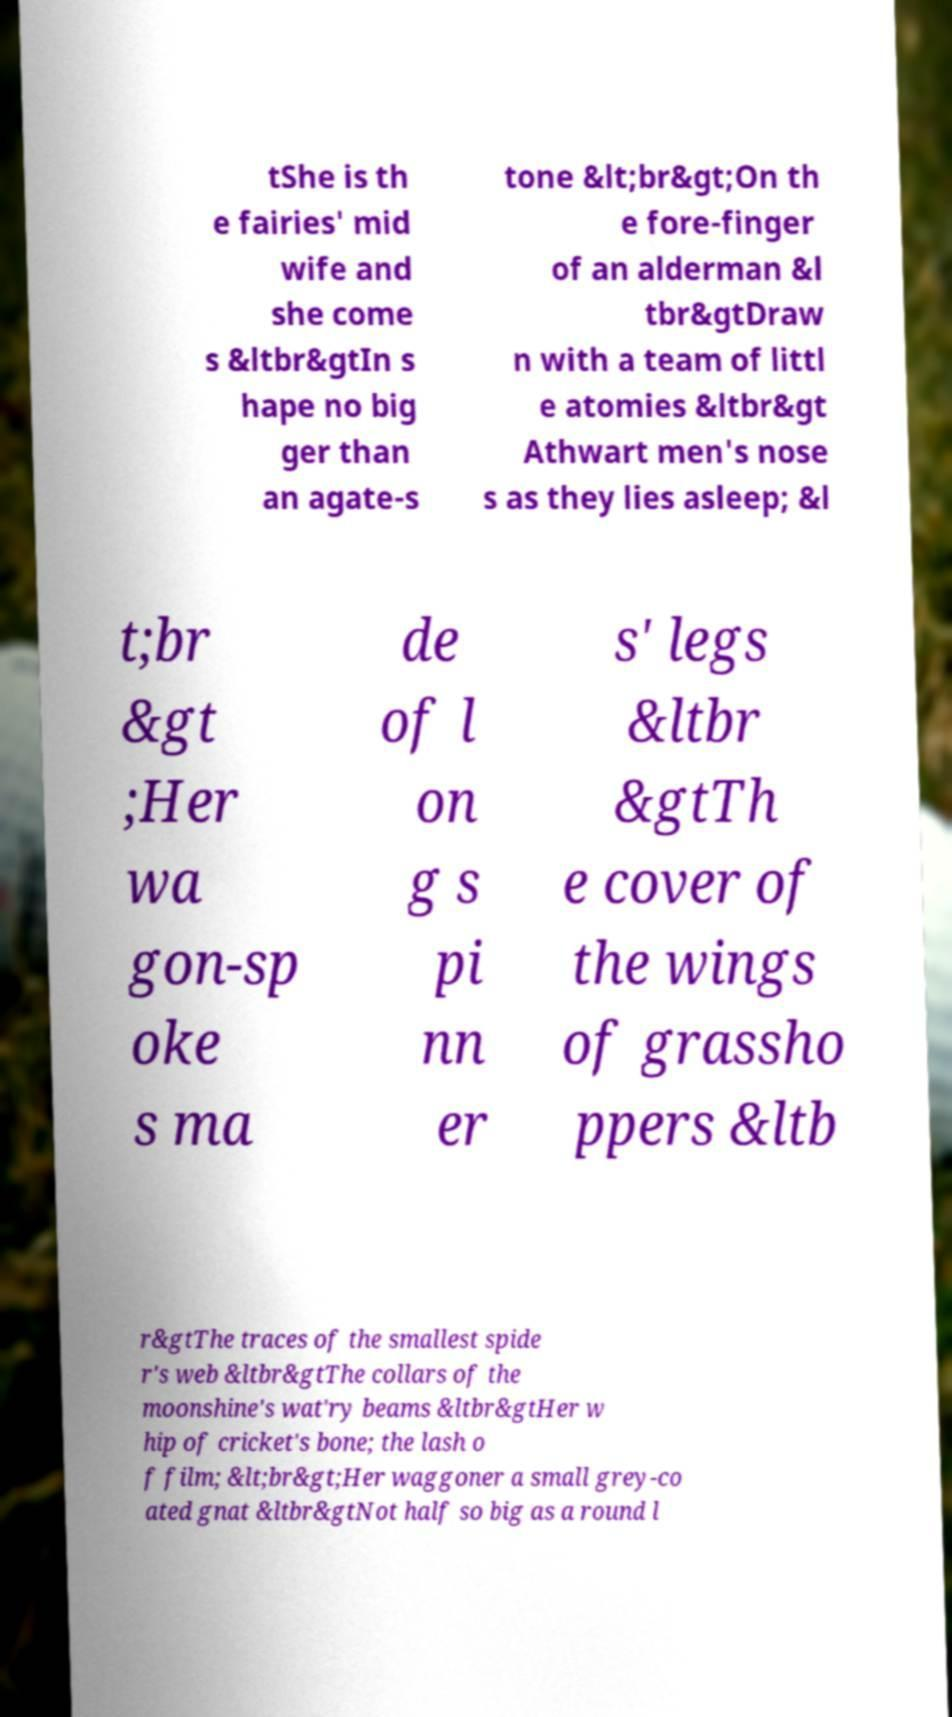Can you read and provide the text displayed in the image?This photo seems to have some interesting text. Can you extract and type it out for me? tShe is th e fairies' mid wife and she come s &ltbr&gtIn s hape no big ger than an agate-s tone &lt;br&gt;On th e fore-finger of an alderman &l tbr&gtDraw n with a team of littl e atomies &ltbr&gt Athwart men's nose s as they lies asleep; &l t;br &gt ;Her wa gon-sp oke s ma de of l on g s pi nn er s' legs &ltbr &gtTh e cover of the wings of grassho ppers &ltb r&gtThe traces of the smallest spide r's web &ltbr&gtThe collars of the moonshine's wat'ry beams &ltbr&gtHer w hip of cricket's bone; the lash o f film; &lt;br&gt;Her waggoner a small grey-co ated gnat &ltbr&gtNot half so big as a round l 